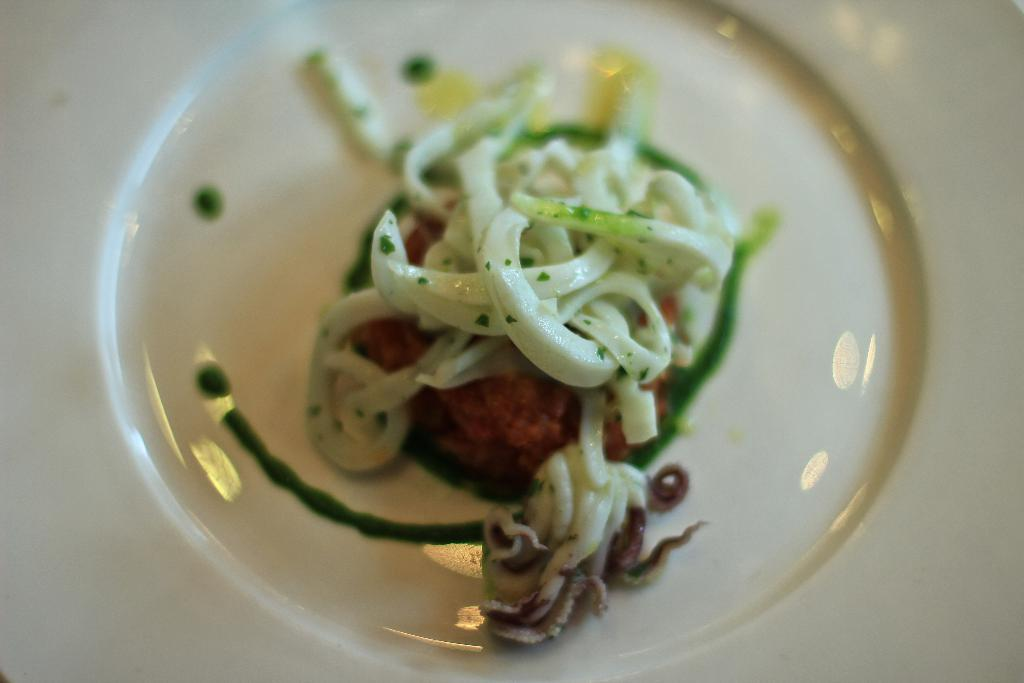What is the main subject of the image? The main subject of the image is food. How is the food contained in the image? The food is in a glass bowl. What type of quince is being used as a mask in the image? There is no quince or mask present in the image; it only features food in a glass bowl. 